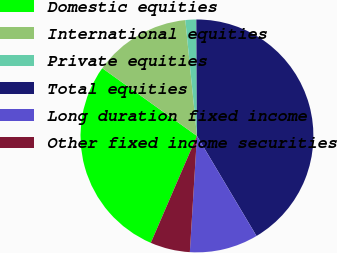<chart> <loc_0><loc_0><loc_500><loc_500><pie_chart><fcel>Domestic equities<fcel>International equities<fcel>Private equities<fcel>Total equities<fcel>Long duration fixed income<fcel>Other fixed income securities<nl><fcel>28.4%<fcel>13.52%<fcel>1.51%<fcel>41.54%<fcel>9.52%<fcel>5.51%<nl></chart> 